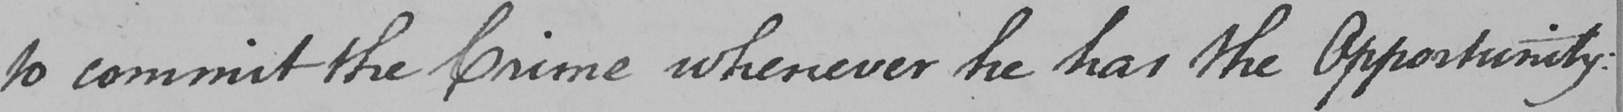Transcribe the text shown in this historical manuscript line. to commit the Crime whenever he has the Opportunity : 